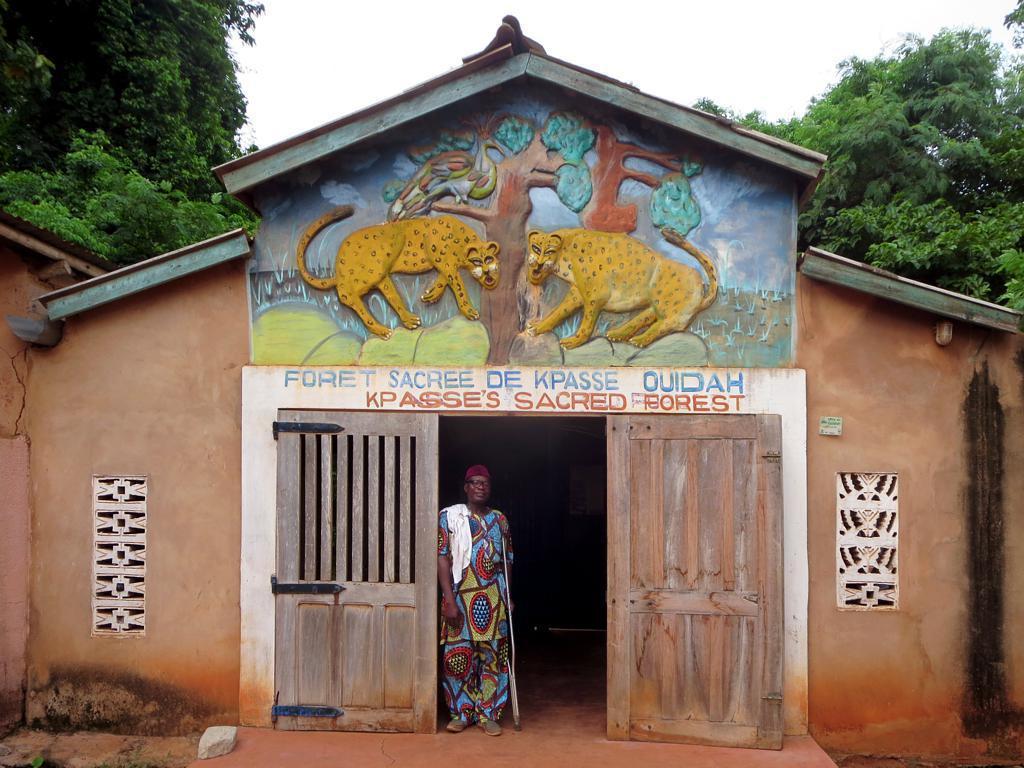How would you summarize this image in a sentence or two? In this image I can see a person wearing dress which is blue, yellow and red in color is standing and holding a stick and I can see a white colored cloth on him. In the background I can see a house and on the house I can see the sculpture of two tigers and a tree and I can see few trees and the sky in the background. 